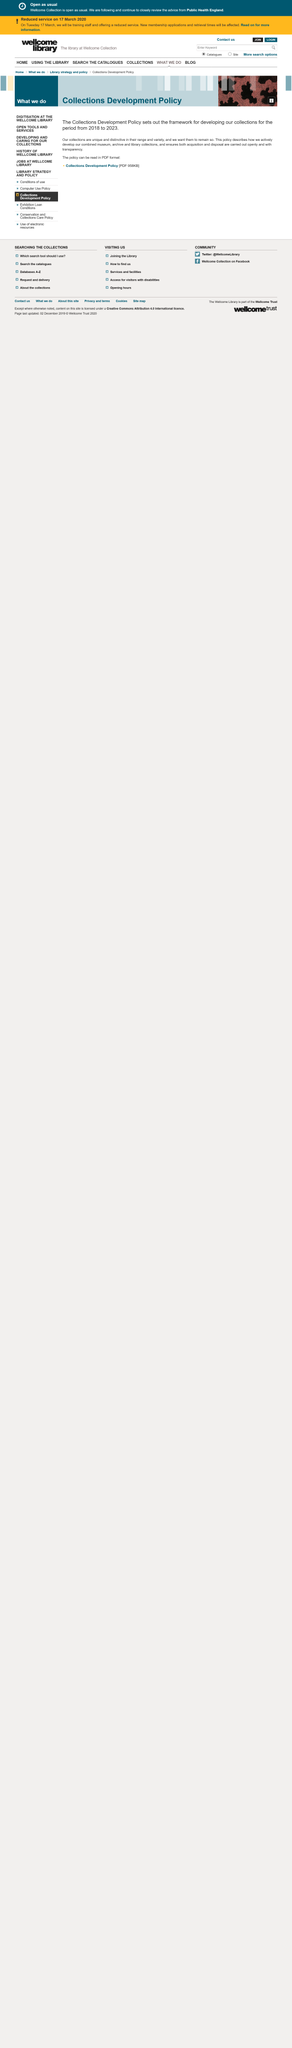Give some essential details in this illustration. The Collections Development Policy sets the framework for the development of our collections out to 2023. It is effective in guiding the process of acquiring materials for our collections. The Collections Development Policy applies not only to museums, but also to the combined museum, archive, and library collections. The Collections Development Policy is a document that outlines the guidelines for acquiring and managing collections from 2018 to 2023. 